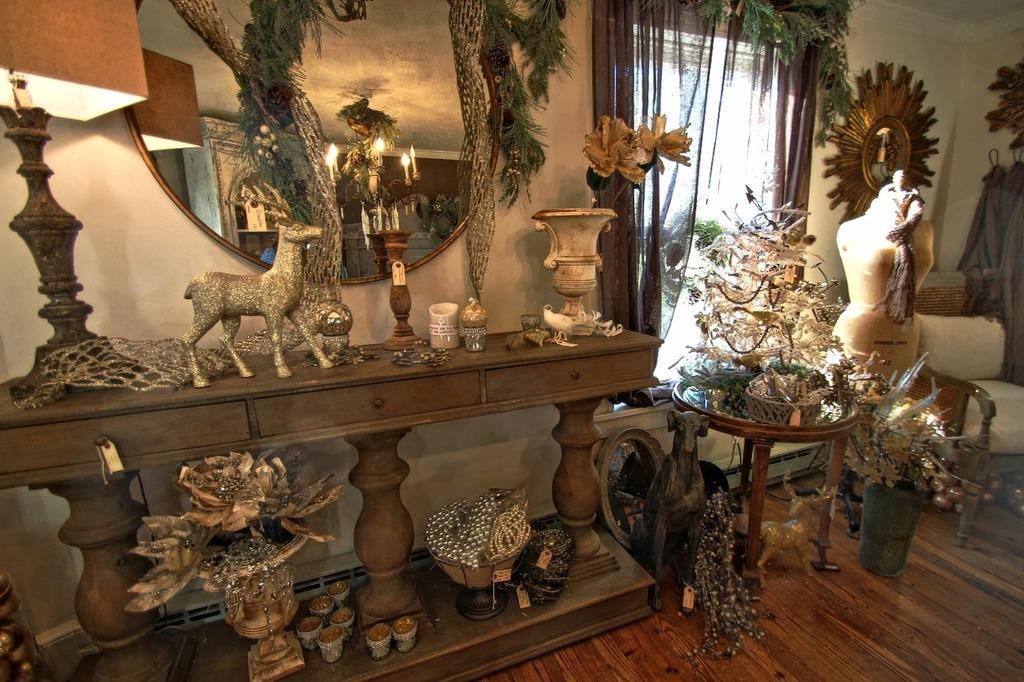Please provide a concise description of this image. In this image we can see a table with drawers, on the table there is a lamp, dolls, flower vase, candle stand and few objects, and under the table there is a flower vase, bowl with some decorative items and few object, there is another table near the window, on the table there are few objects and beside the table there are dolls and few decorative items on the floor, there is a chair, a mannequin with a scarf, there are clothes hanged to the wall and mirrors and decorative item to the wall and a curtain to the window. 